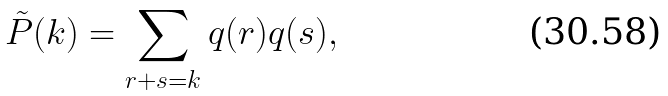<formula> <loc_0><loc_0><loc_500><loc_500>\tilde { P } ( k ) = \sum _ { r + s = k } q ( r ) q ( s ) ,</formula> 